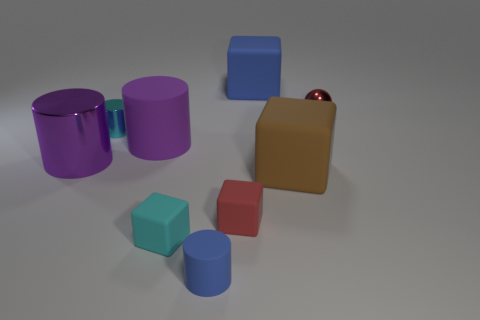If I were to move the tiny metal sphere to directly between the two purple cylinders, would it be equidistant to both? If you placed the tiny metal sphere directly between the two purple cylinders, it appears that it would be equidistant to both, creating a symmetric arrangement among these three objects. 